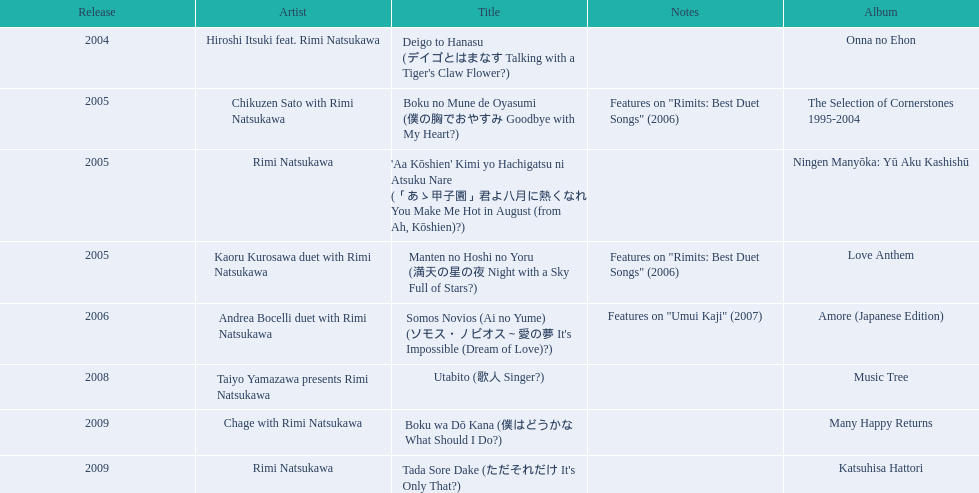What are all of the titles? Deigo to Hanasu (デイゴとはまなす Talking with a Tiger's Claw Flower?), Boku no Mune de Oyasumi (僕の胸でおやすみ Goodbye with My Heart?), 'Aa Kōshien' Kimi yo Hachigatsu ni Atsuku Nare (「あゝ甲子園」君よ八月に熱くなれ You Make Me Hot in August (from Ah, Kōshien)?), Manten no Hoshi no Yoru (満天の星の夜 Night with a Sky Full of Stars?), Somos Novios (Ai no Yume) (ソモス・ノビオス～愛の夢 It's Impossible (Dream of Love)?), Utabito (歌人 Singer?), Boku wa Dō Kana (僕はどうかな What Should I Do?), Tada Sore Dake (ただそれだけ It's Only That?). What are their notes? , Features on "Rimits: Best Duet Songs" (2006), , Features on "Rimits: Best Duet Songs" (2006), Features on "Umui Kaji" (2007), , , . Which title shares its notes with manten no hoshi no yoru (man tian noxing noye night with a sky full of stars?)? Boku no Mune de Oyasumi (僕の胸でおやすみ Goodbye with My Heart?). 